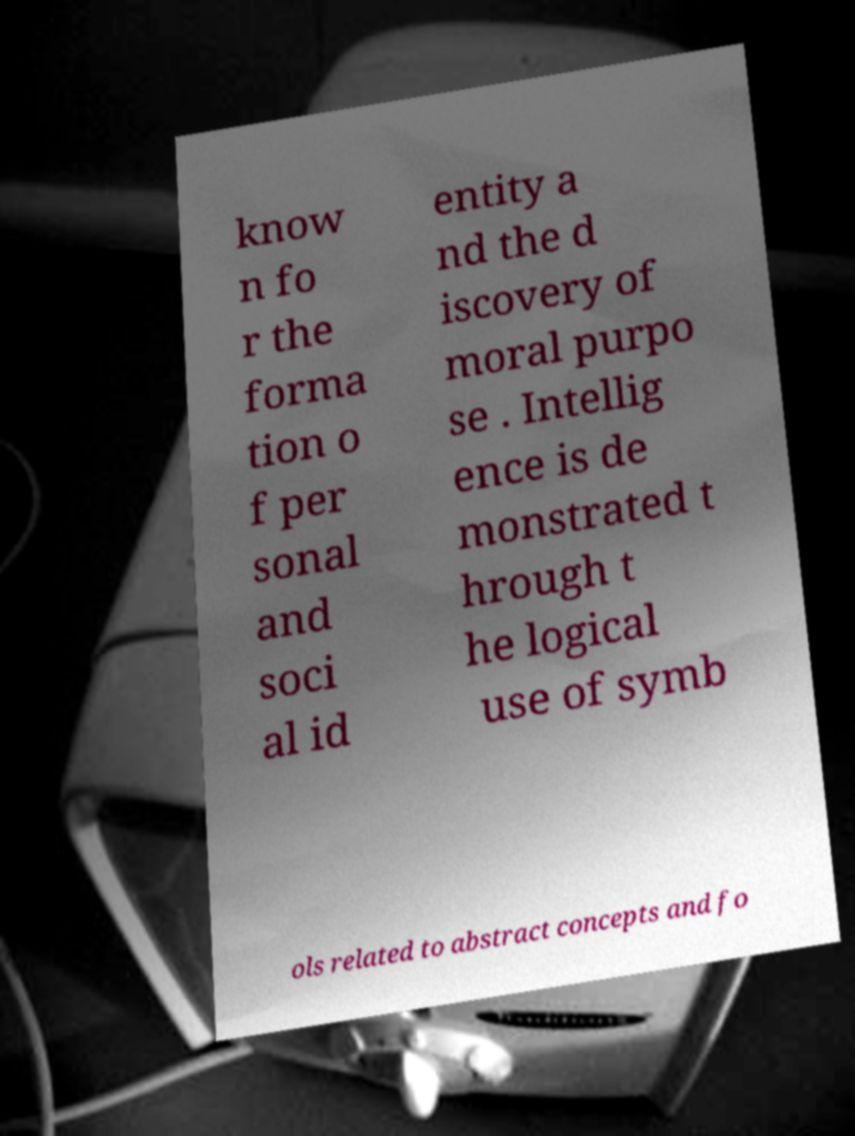Can you read and provide the text displayed in the image?This photo seems to have some interesting text. Can you extract and type it out for me? know n fo r the forma tion o f per sonal and soci al id entity a nd the d iscovery of moral purpo se . Intellig ence is de monstrated t hrough t he logical use of symb ols related to abstract concepts and fo 